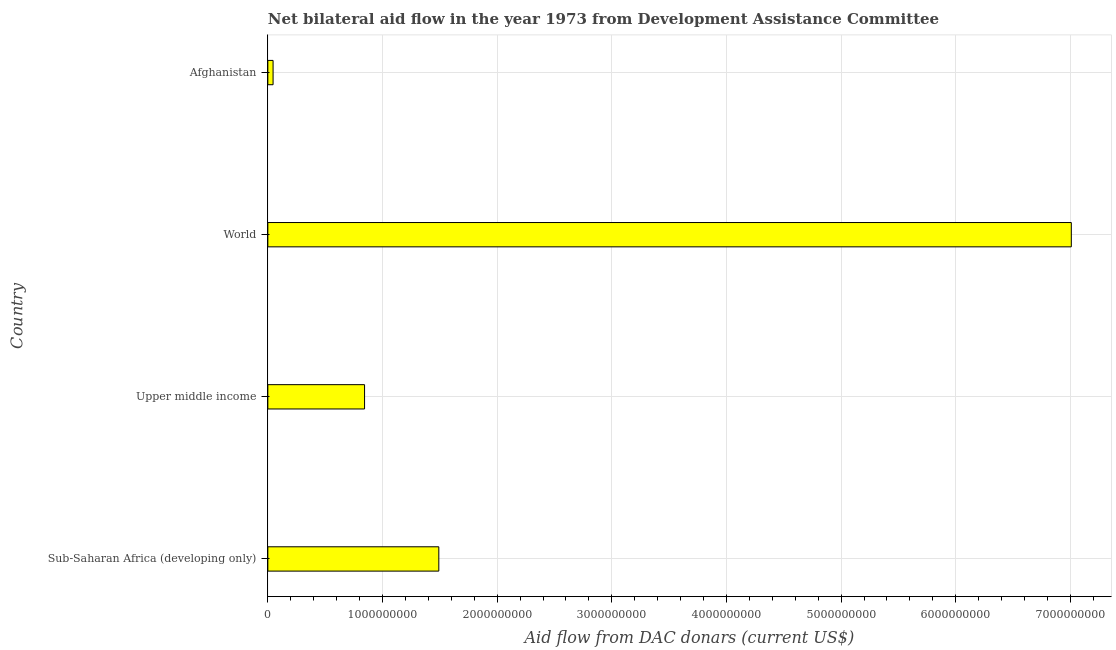Does the graph contain any zero values?
Provide a short and direct response. No. Does the graph contain grids?
Ensure brevity in your answer.  Yes. What is the title of the graph?
Offer a very short reply. Net bilateral aid flow in the year 1973 from Development Assistance Committee. What is the label or title of the X-axis?
Offer a very short reply. Aid flow from DAC donars (current US$). What is the net bilateral aid flows from dac donors in Sub-Saharan Africa (developing only)?
Give a very brief answer. 1.49e+09. Across all countries, what is the maximum net bilateral aid flows from dac donors?
Your answer should be very brief. 7.01e+09. Across all countries, what is the minimum net bilateral aid flows from dac donors?
Your response must be concise. 4.57e+07. In which country was the net bilateral aid flows from dac donors maximum?
Give a very brief answer. World. In which country was the net bilateral aid flows from dac donors minimum?
Your answer should be very brief. Afghanistan. What is the sum of the net bilateral aid flows from dac donors?
Offer a very short reply. 9.39e+09. What is the difference between the net bilateral aid flows from dac donors in Afghanistan and World?
Ensure brevity in your answer.  -6.96e+09. What is the average net bilateral aid flows from dac donors per country?
Give a very brief answer. 2.35e+09. What is the median net bilateral aid flows from dac donors?
Ensure brevity in your answer.  1.17e+09. What is the ratio of the net bilateral aid flows from dac donors in Sub-Saharan Africa (developing only) to that in World?
Provide a succinct answer. 0.21. Is the net bilateral aid flows from dac donors in Sub-Saharan Africa (developing only) less than that in Upper middle income?
Your answer should be very brief. No. Is the difference between the net bilateral aid flows from dac donors in Sub-Saharan Africa (developing only) and World greater than the difference between any two countries?
Provide a succinct answer. No. What is the difference between the highest and the second highest net bilateral aid flows from dac donors?
Keep it short and to the point. 5.52e+09. What is the difference between the highest and the lowest net bilateral aid flows from dac donors?
Offer a very short reply. 6.96e+09. What is the difference between two consecutive major ticks on the X-axis?
Offer a terse response. 1.00e+09. What is the Aid flow from DAC donars (current US$) of Sub-Saharan Africa (developing only)?
Your answer should be compact. 1.49e+09. What is the Aid flow from DAC donars (current US$) in Upper middle income?
Your answer should be very brief. 8.44e+08. What is the Aid flow from DAC donars (current US$) in World?
Offer a very short reply. 7.01e+09. What is the Aid flow from DAC donars (current US$) of Afghanistan?
Offer a very short reply. 4.57e+07. What is the difference between the Aid flow from DAC donars (current US$) in Sub-Saharan Africa (developing only) and Upper middle income?
Make the answer very short. 6.48e+08. What is the difference between the Aid flow from DAC donars (current US$) in Sub-Saharan Africa (developing only) and World?
Keep it short and to the point. -5.52e+09. What is the difference between the Aid flow from DAC donars (current US$) in Sub-Saharan Africa (developing only) and Afghanistan?
Provide a short and direct response. 1.45e+09. What is the difference between the Aid flow from DAC donars (current US$) in Upper middle income and World?
Offer a terse response. -6.16e+09. What is the difference between the Aid flow from DAC donars (current US$) in Upper middle income and Afghanistan?
Give a very brief answer. 7.98e+08. What is the difference between the Aid flow from DAC donars (current US$) in World and Afghanistan?
Make the answer very short. 6.96e+09. What is the ratio of the Aid flow from DAC donars (current US$) in Sub-Saharan Africa (developing only) to that in Upper middle income?
Your answer should be very brief. 1.77. What is the ratio of the Aid flow from DAC donars (current US$) in Sub-Saharan Africa (developing only) to that in World?
Provide a short and direct response. 0.21. What is the ratio of the Aid flow from DAC donars (current US$) in Sub-Saharan Africa (developing only) to that in Afghanistan?
Offer a very short reply. 32.62. What is the ratio of the Aid flow from DAC donars (current US$) in Upper middle income to that in World?
Give a very brief answer. 0.12. What is the ratio of the Aid flow from DAC donars (current US$) in Upper middle income to that in Afghanistan?
Keep it short and to the point. 18.45. What is the ratio of the Aid flow from DAC donars (current US$) in World to that in Afghanistan?
Keep it short and to the point. 153.31. 